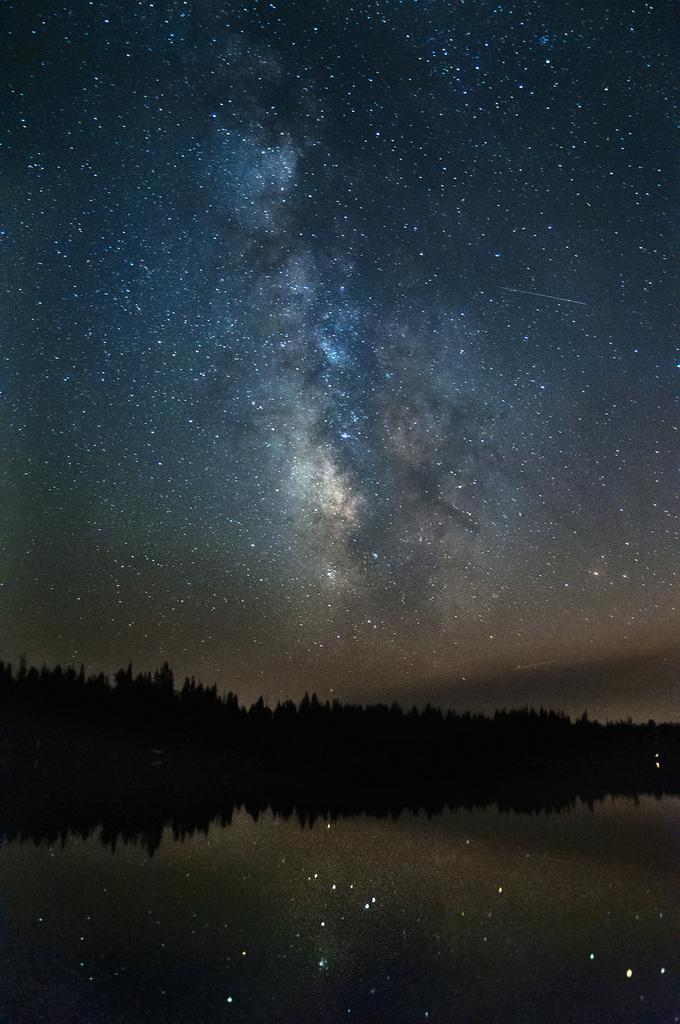How would you summarize this image in a sentence or two? This picture shows water, trees and sky with stars. 